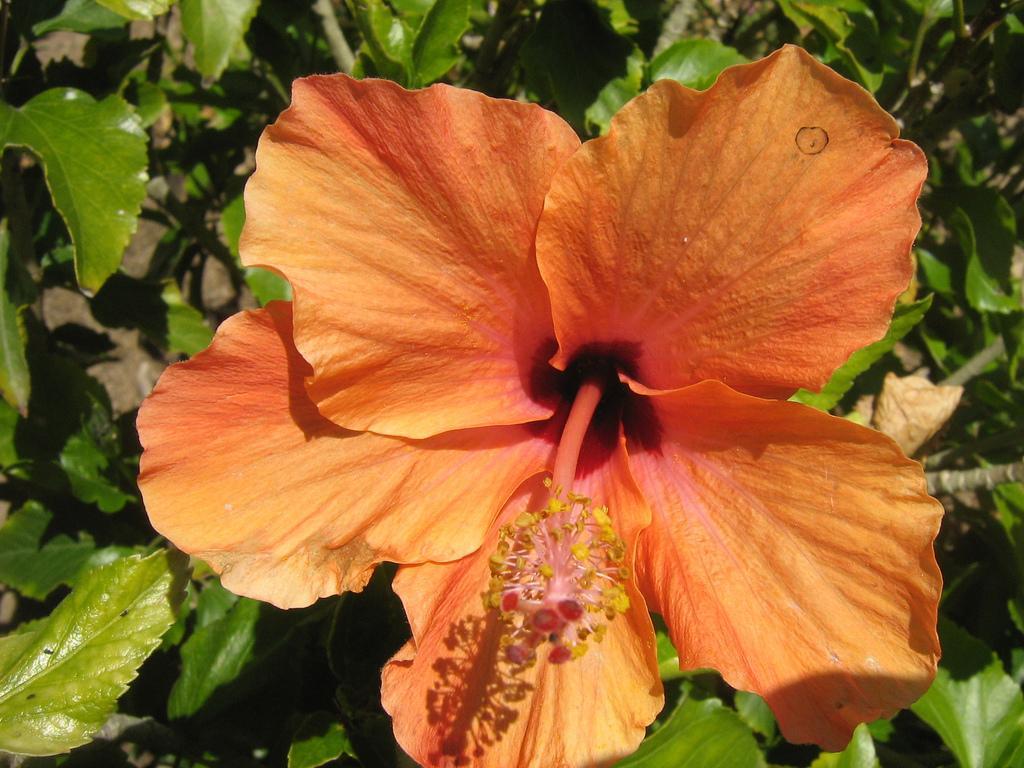In one or two sentences, can you explain what this image depicts? Here we can see planets with a flower. 